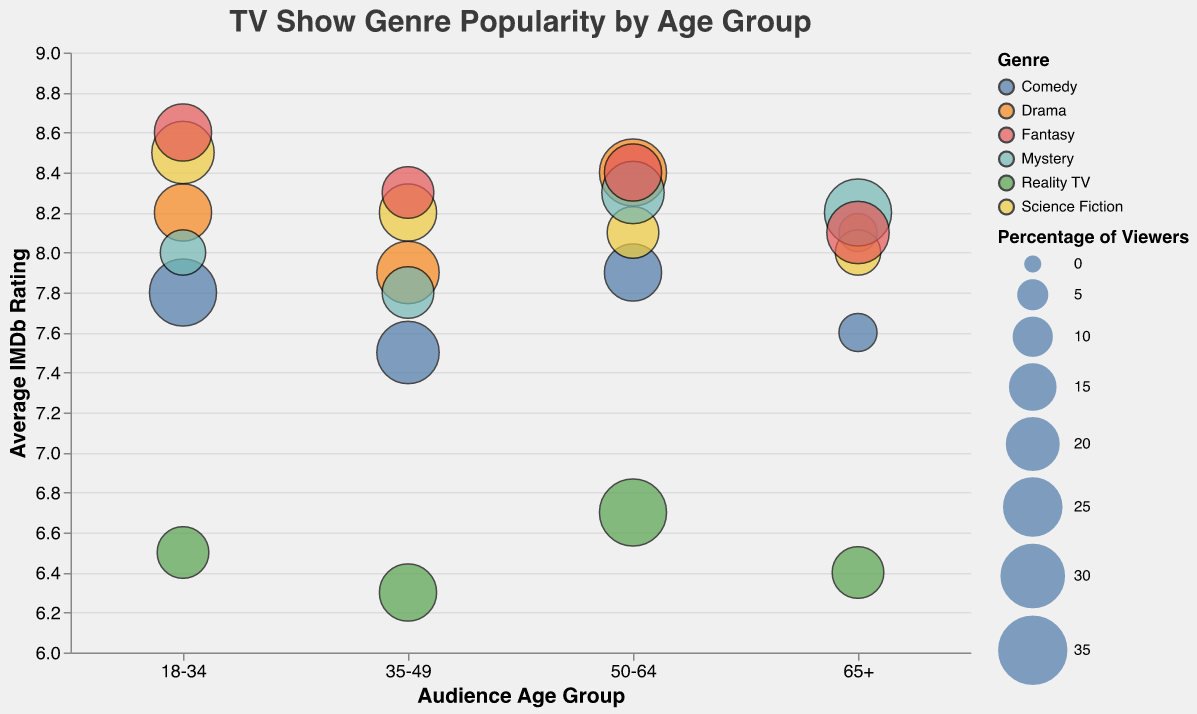What is the title of the figure? The title is usually at the very top of the figure. In this case, it explicitly states the focus of the visualization.
Answer: TV Show Genre Popularity by Age Group Which genre has the highest average IMDb rating for the 18-34 age group? By looking at the 18-34 age group on the x-axis and checking the y-axis for the highest IMDb rating for that age group, we can identify the genre.
Answer: Fantasy What is the percentage of viewers for Comedy in the 50-64 age group? Locate Comedy, then find the bubble corresponding to the 50-64 age group and check the size of the bubble. The size legend helps interpret the percentage of viewers.
Answer: 25% Between Drama and Science Fiction, which genre has a higher IMDb rating among viewers aged 50-64? Compare the heights of the bubbles for Drama and Science Fiction in the 50-64 age group. The y-axis indicates the IMDb rating.
Answer: Drama How does the popularity of Reality TV compare between the 18-34 and 65+ age groups? Compare the size of the bubbles representing Reality TV in both the 18-34 and 65+ age groups. The bigger the bubble, the higher the percentage of viewers.
Answer: They are both at 20% Which genre shows the largest variation in average IMDb ratings across all age groups? Look for the genre whose bubbles are spread out the most along the y-axis (IMDb ratings) across different age groups. This indicates the variation in its IMDb ratings.
Answer: Drama What is the average IMDb rating for Science Fiction in the age groups 35-49 and 50-64 combined? Find the IMDb ratings for Science Fiction in the 35-49 and 50-64 age groups, then calculate the average of these ratings. \((8.2+8.1)/2\)
Answer: 8.15 How does the percentage of viewers for Mystery in the 65+ age group compare with that of Reality TV in the 50-64 age group? Compare the size of the bubble for Mystery in the 65+ age group with that of Reality TV in the 50-64 age group. The sizes represent percentage viewers, so compare these sizes.
Answer: Both are 35% Which genre has the smallest bubble in the 65+ age group, and what does it tell us about the popularity among that age group? Find the smallest bubble in the 65+ age group and identify its genre. This indicates the genre has the least percentage of viewers in the given age group.
Answer: Drama, it has only 10% of viewers What is the sum of the IMDb ratings for Fantasy across all age groups? Add the IMDb ratings for Fantasy in each age group: \(8.6 + 8.3 + 8.4 + 8.1\).
Answer: 33.4 